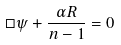<formula> <loc_0><loc_0><loc_500><loc_500>\Box \psi + \frac { \alpha R } { n - 1 } = 0</formula> 